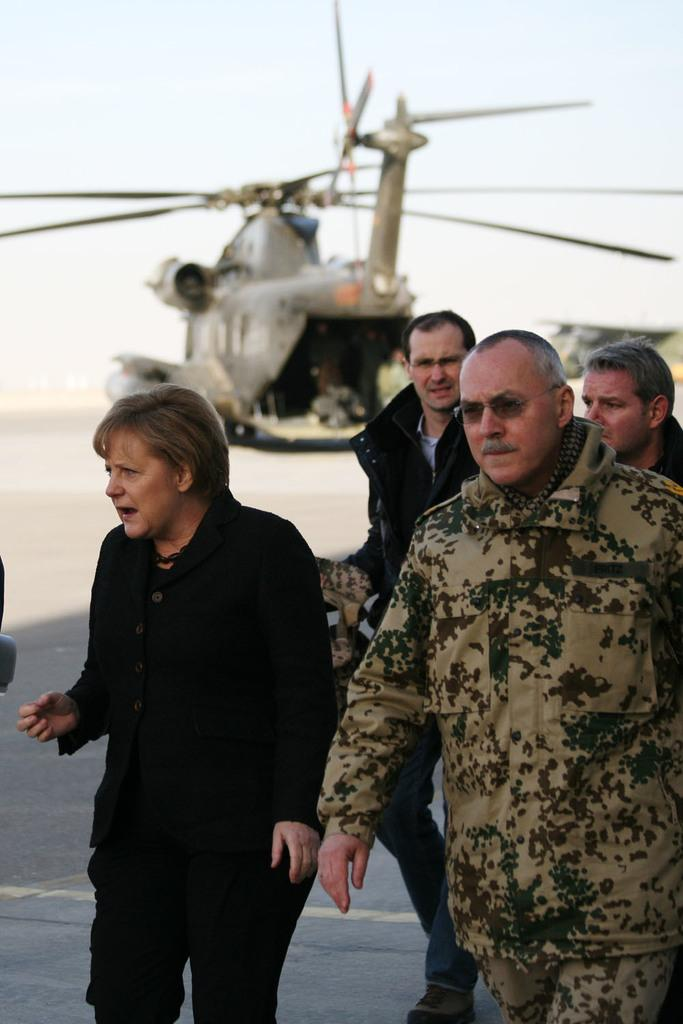What is happening in the foreground of the image? There are people walking in the foreground of the image. Can you describe any other objects or subjects in the image? Yes, there is a helicopter visible in the image, although it is blurry. What is the reaction of the people when someone sneezes in the image? There is no indication in the image that anyone has sneezed, so it's not possible to determine the reaction of the people. 